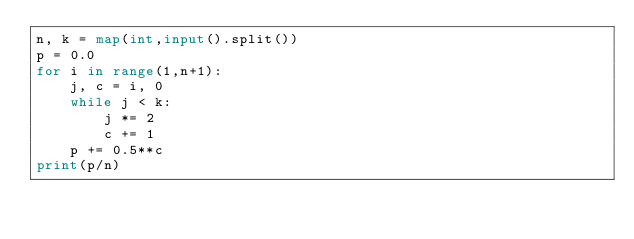Convert code to text. <code><loc_0><loc_0><loc_500><loc_500><_Python_>n, k = map(int,input().split())
p = 0.0
for i in range(1,n+1):
    j, c = i, 0
    while j < k:
        j *= 2
        c += 1
    p += 0.5**c
print(p/n)</code> 